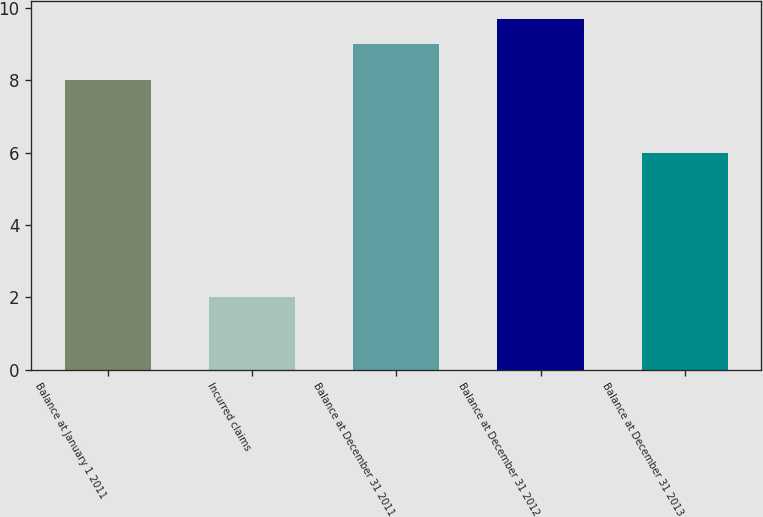Convert chart to OTSL. <chart><loc_0><loc_0><loc_500><loc_500><bar_chart><fcel>Balance at January 1 2011<fcel>Incurred claims<fcel>Balance at December 31 2011<fcel>Balance at December 31 2012<fcel>Balance at December 31 2013<nl><fcel>8<fcel>2<fcel>9<fcel>9.7<fcel>6<nl></chart> 